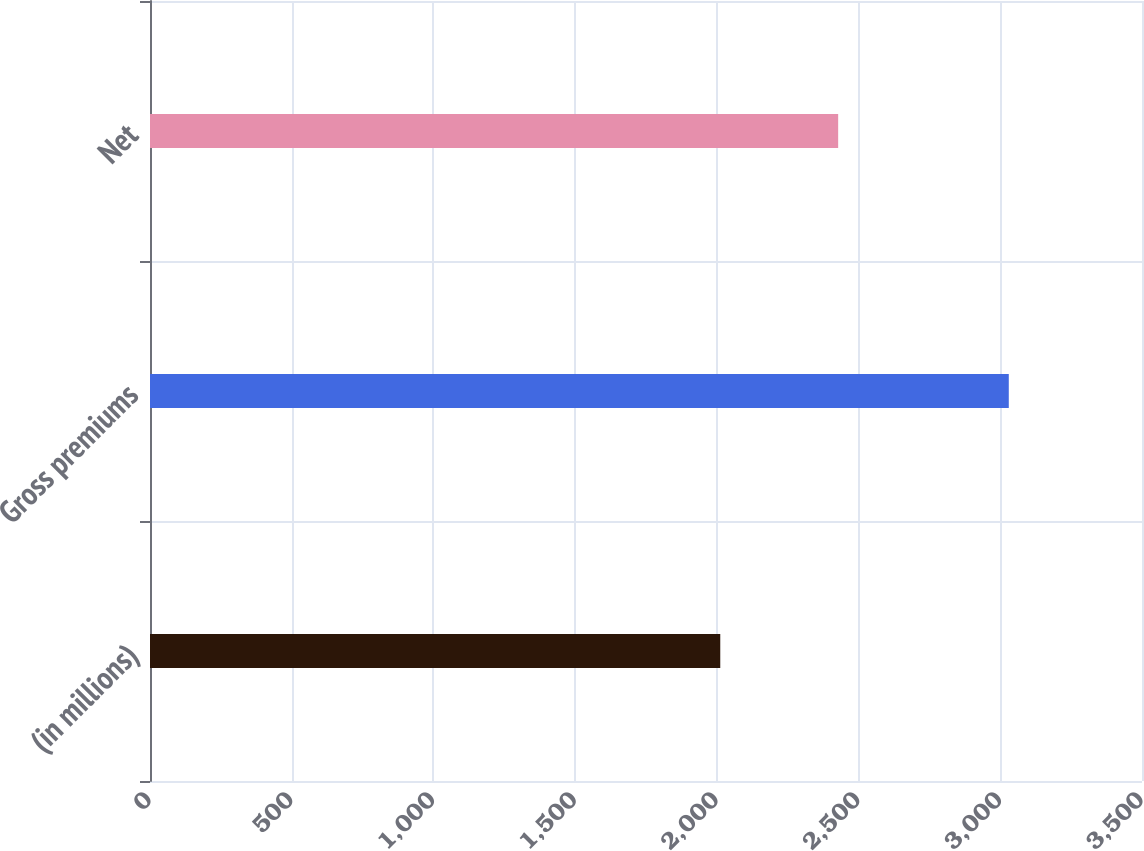<chart> <loc_0><loc_0><loc_500><loc_500><bar_chart><fcel>(in millions)<fcel>Gross premiums<fcel>Net<nl><fcel>2012<fcel>3030<fcel>2428<nl></chart> 